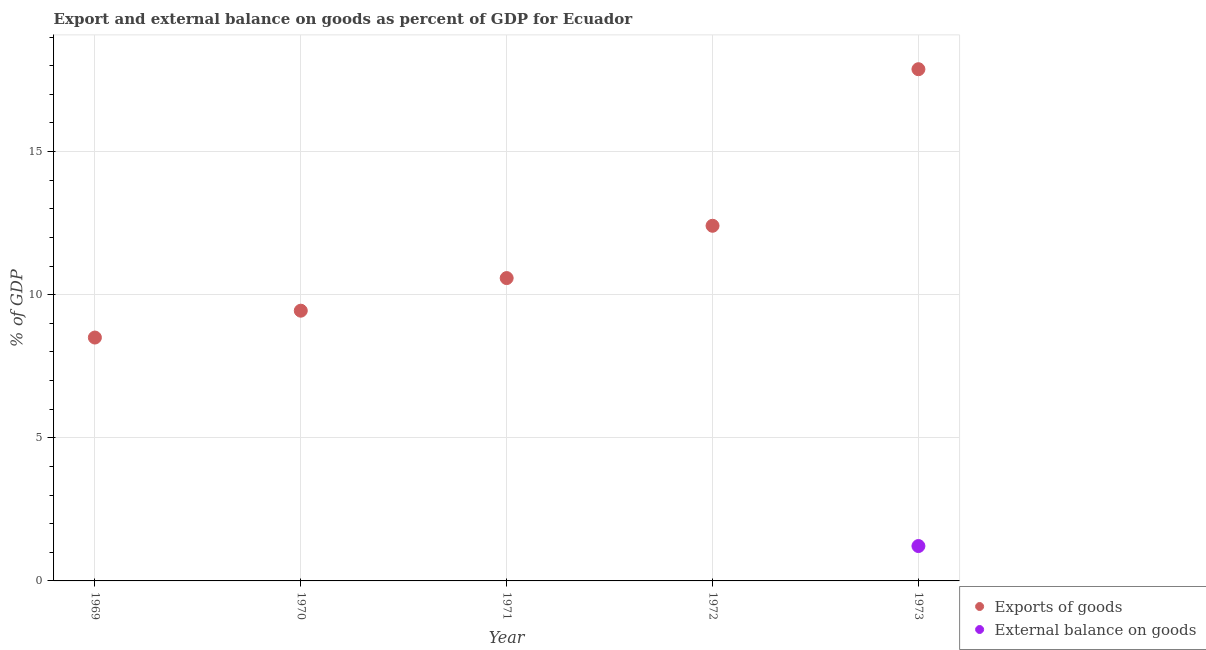How many different coloured dotlines are there?
Your answer should be very brief. 2. Is the number of dotlines equal to the number of legend labels?
Keep it short and to the point. No. What is the external balance on goods as percentage of gdp in 1973?
Provide a short and direct response. 1.22. Across all years, what is the maximum export of goods as percentage of gdp?
Give a very brief answer. 17.88. Across all years, what is the minimum external balance on goods as percentage of gdp?
Make the answer very short. 0. What is the total external balance on goods as percentage of gdp in the graph?
Offer a terse response. 1.22. What is the difference between the export of goods as percentage of gdp in 1970 and that in 1971?
Your response must be concise. -1.14. What is the difference between the export of goods as percentage of gdp in 1970 and the external balance on goods as percentage of gdp in 1971?
Your response must be concise. 9.44. What is the average external balance on goods as percentage of gdp per year?
Give a very brief answer. 0.24. In the year 1973, what is the difference between the external balance on goods as percentage of gdp and export of goods as percentage of gdp?
Your answer should be compact. -16.66. In how many years, is the export of goods as percentage of gdp greater than 14 %?
Give a very brief answer. 1. What is the ratio of the export of goods as percentage of gdp in 1970 to that in 1973?
Your answer should be very brief. 0.53. Is the export of goods as percentage of gdp in 1969 less than that in 1971?
Ensure brevity in your answer.  Yes. What is the difference between the highest and the second highest export of goods as percentage of gdp?
Your answer should be compact. 5.47. What is the difference between the highest and the lowest export of goods as percentage of gdp?
Offer a very short reply. 9.38. Is the external balance on goods as percentage of gdp strictly less than the export of goods as percentage of gdp over the years?
Make the answer very short. Yes. How many dotlines are there?
Provide a succinct answer. 2. What is the difference between two consecutive major ticks on the Y-axis?
Ensure brevity in your answer.  5. Does the graph contain any zero values?
Provide a succinct answer. Yes. Where does the legend appear in the graph?
Offer a very short reply. Bottom right. What is the title of the graph?
Give a very brief answer. Export and external balance on goods as percent of GDP for Ecuador. Does "Male population" appear as one of the legend labels in the graph?
Provide a short and direct response. No. What is the label or title of the X-axis?
Your response must be concise. Year. What is the label or title of the Y-axis?
Make the answer very short. % of GDP. What is the % of GDP of Exports of goods in 1969?
Make the answer very short. 8.5. What is the % of GDP of External balance on goods in 1969?
Provide a short and direct response. 0. What is the % of GDP of Exports of goods in 1970?
Keep it short and to the point. 9.44. What is the % of GDP of Exports of goods in 1971?
Ensure brevity in your answer.  10.58. What is the % of GDP in Exports of goods in 1972?
Your response must be concise. 12.41. What is the % of GDP of Exports of goods in 1973?
Offer a terse response. 17.88. What is the % of GDP in External balance on goods in 1973?
Offer a very short reply. 1.22. Across all years, what is the maximum % of GDP in Exports of goods?
Your answer should be compact. 17.88. Across all years, what is the maximum % of GDP in External balance on goods?
Offer a terse response. 1.22. Across all years, what is the minimum % of GDP in Exports of goods?
Offer a terse response. 8.5. What is the total % of GDP in Exports of goods in the graph?
Provide a short and direct response. 58.81. What is the total % of GDP in External balance on goods in the graph?
Keep it short and to the point. 1.22. What is the difference between the % of GDP in Exports of goods in 1969 and that in 1970?
Keep it short and to the point. -0.94. What is the difference between the % of GDP in Exports of goods in 1969 and that in 1971?
Provide a succinct answer. -2.08. What is the difference between the % of GDP of Exports of goods in 1969 and that in 1972?
Offer a very short reply. -3.9. What is the difference between the % of GDP of Exports of goods in 1969 and that in 1973?
Provide a short and direct response. -9.38. What is the difference between the % of GDP in Exports of goods in 1970 and that in 1971?
Your response must be concise. -1.14. What is the difference between the % of GDP in Exports of goods in 1970 and that in 1972?
Your answer should be very brief. -2.97. What is the difference between the % of GDP in Exports of goods in 1970 and that in 1973?
Give a very brief answer. -8.44. What is the difference between the % of GDP in Exports of goods in 1971 and that in 1972?
Your answer should be compact. -1.83. What is the difference between the % of GDP in Exports of goods in 1971 and that in 1973?
Ensure brevity in your answer.  -7.3. What is the difference between the % of GDP in Exports of goods in 1972 and that in 1973?
Your answer should be compact. -5.47. What is the difference between the % of GDP in Exports of goods in 1969 and the % of GDP in External balance on goods in 1973?
Provide a short and direct response. 7.28. What is the difference between the % of GDP in Exports of goods in 1970 and the % of GDP in External balance on goods in 1973?
Offer a terse response. 8.22. What is the difference between the % of GDP in Exports of goods in 1971 and the % of GDP in External balance on goods in 1973?
Offer a very short reply. 9.36. What is the difference between the % of GDP in Exports of goods in 1972 and the % of GDP in External balance on goods in 1973?
Provide a short and direct response. 11.19. What is the average % of GDP of Exports of goods per year?
Your answer should be compact. 11.76. What is the average % of GDP of External balance on goods per year?
Your answer should be very brief. 0.24. In the year 1973, what is the difference between the % of GDP of Exports of goods and % of GDP of External balance on goods?
Ensure brevity in your answer.  16.66. What is the ratio of the % of GDP of Exports of goods in 1969 to that in 1970?
Ensure brevity in your answer.  0.9. What is the ratio of the % of GDP of Exports of goods in 1969 to that in 1971?
Offer a terse response. 0.8. What is the ratio of the % of GDP of Exports of goods in 1969 to that in 1972?
Provide a short and direct response. 0.69. What is the ratio of the % of GDP in Exports of goods in 1969 to that in 1973?
Provide a succinct answer. 0.48. What is the ratio of the % of GDP of Exports of goods in 1970 to that in 1971?
Your answer should be compact. 0.89. What is the ratio of the % of GDP in Exports of goods in 1970 to that in 1972?
Provide a short and direct response. 0.76. What is the ratio of the % of GDP of Exports of goods in 1970 to that in 1973?
Provide a succinct answer. 0.53. What is the ratio of the % of GDP of Exports of goods in 1971 to that in 1972?
Offer a terse response. 0.85. What is the ratio of the % of GDP of Exports of goods in 1971 to that in 1973?
Ensure brevity in your answer.  0.59. What is the ratio of the % of GDP of Exports of goods in 1972 to that in 1973?
Offer a very short reply. 0.69. What is the difference between the highest and the second highest % of GDP in Exports of goods?
Provide a short and direct response. 5.47. What is the difference between the highest and the lowest % of GDP of Exports of goods?
Provide a short and direct response. 9.38. What is the difference between the highest and the lowest % of GDP of External balance on goods?
Offer a terse response. 1.22. 